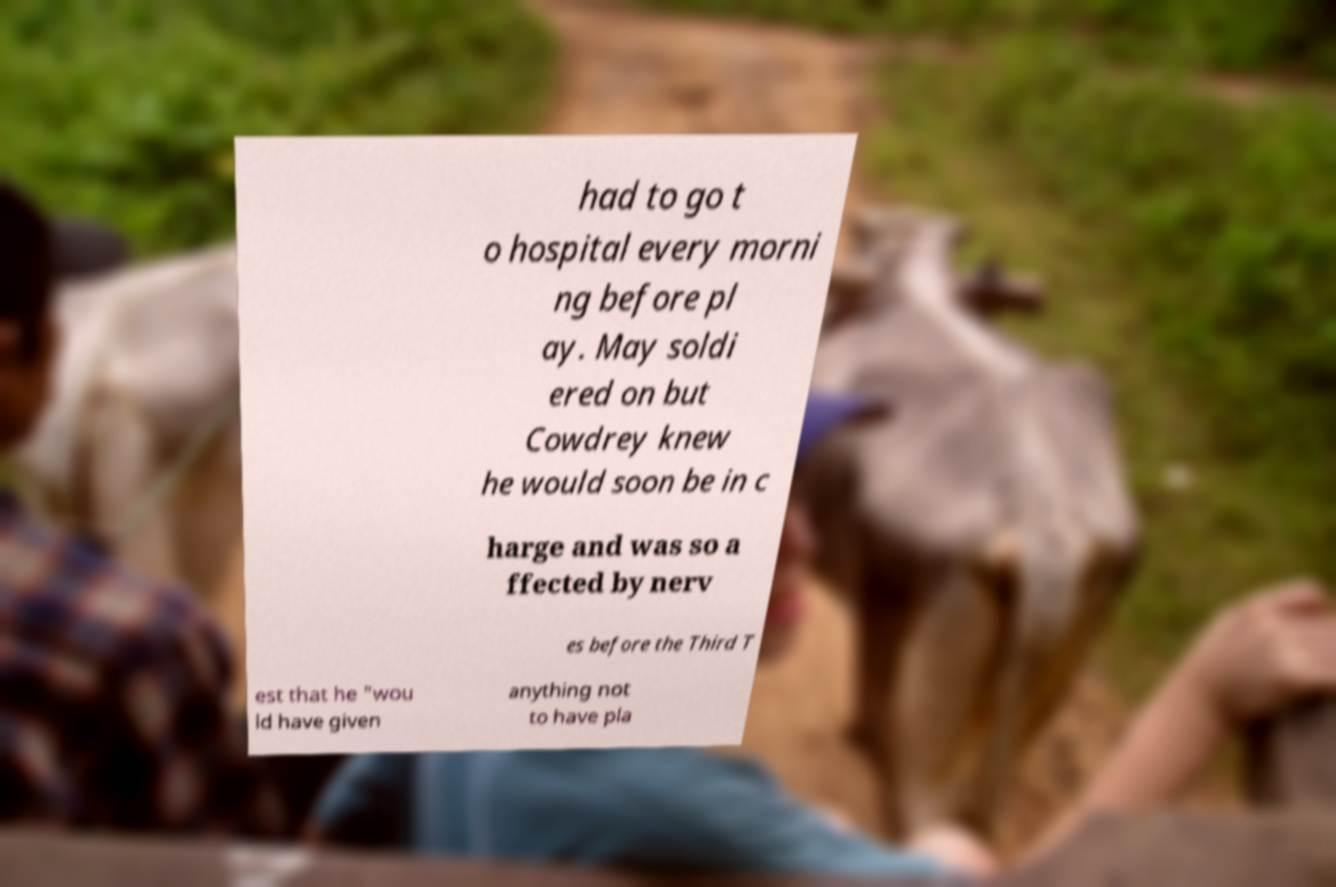Please read and relay the text visible in this image. What does it say? had to go t o hospital every morni ng before pl ay. May soldi ered on but Cowdrey knew he would soon be in c harge and was so a ffected by nerv es before the Third T est that he "wou ld have given anything not to have pla 